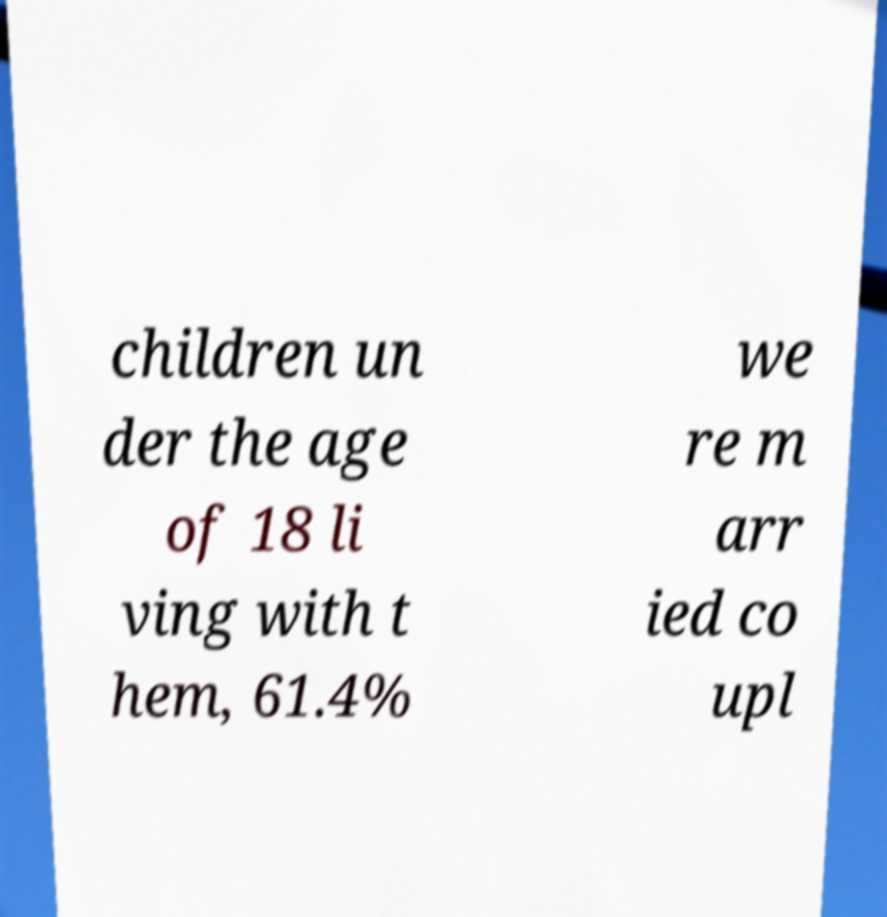Can you read and provide the text displayed in the image?This photo seems to have some interesting text. Can you extract and type it out for me? children un der the age of 18 li ving with t hem, 61.4% we re m arr ied co upl 